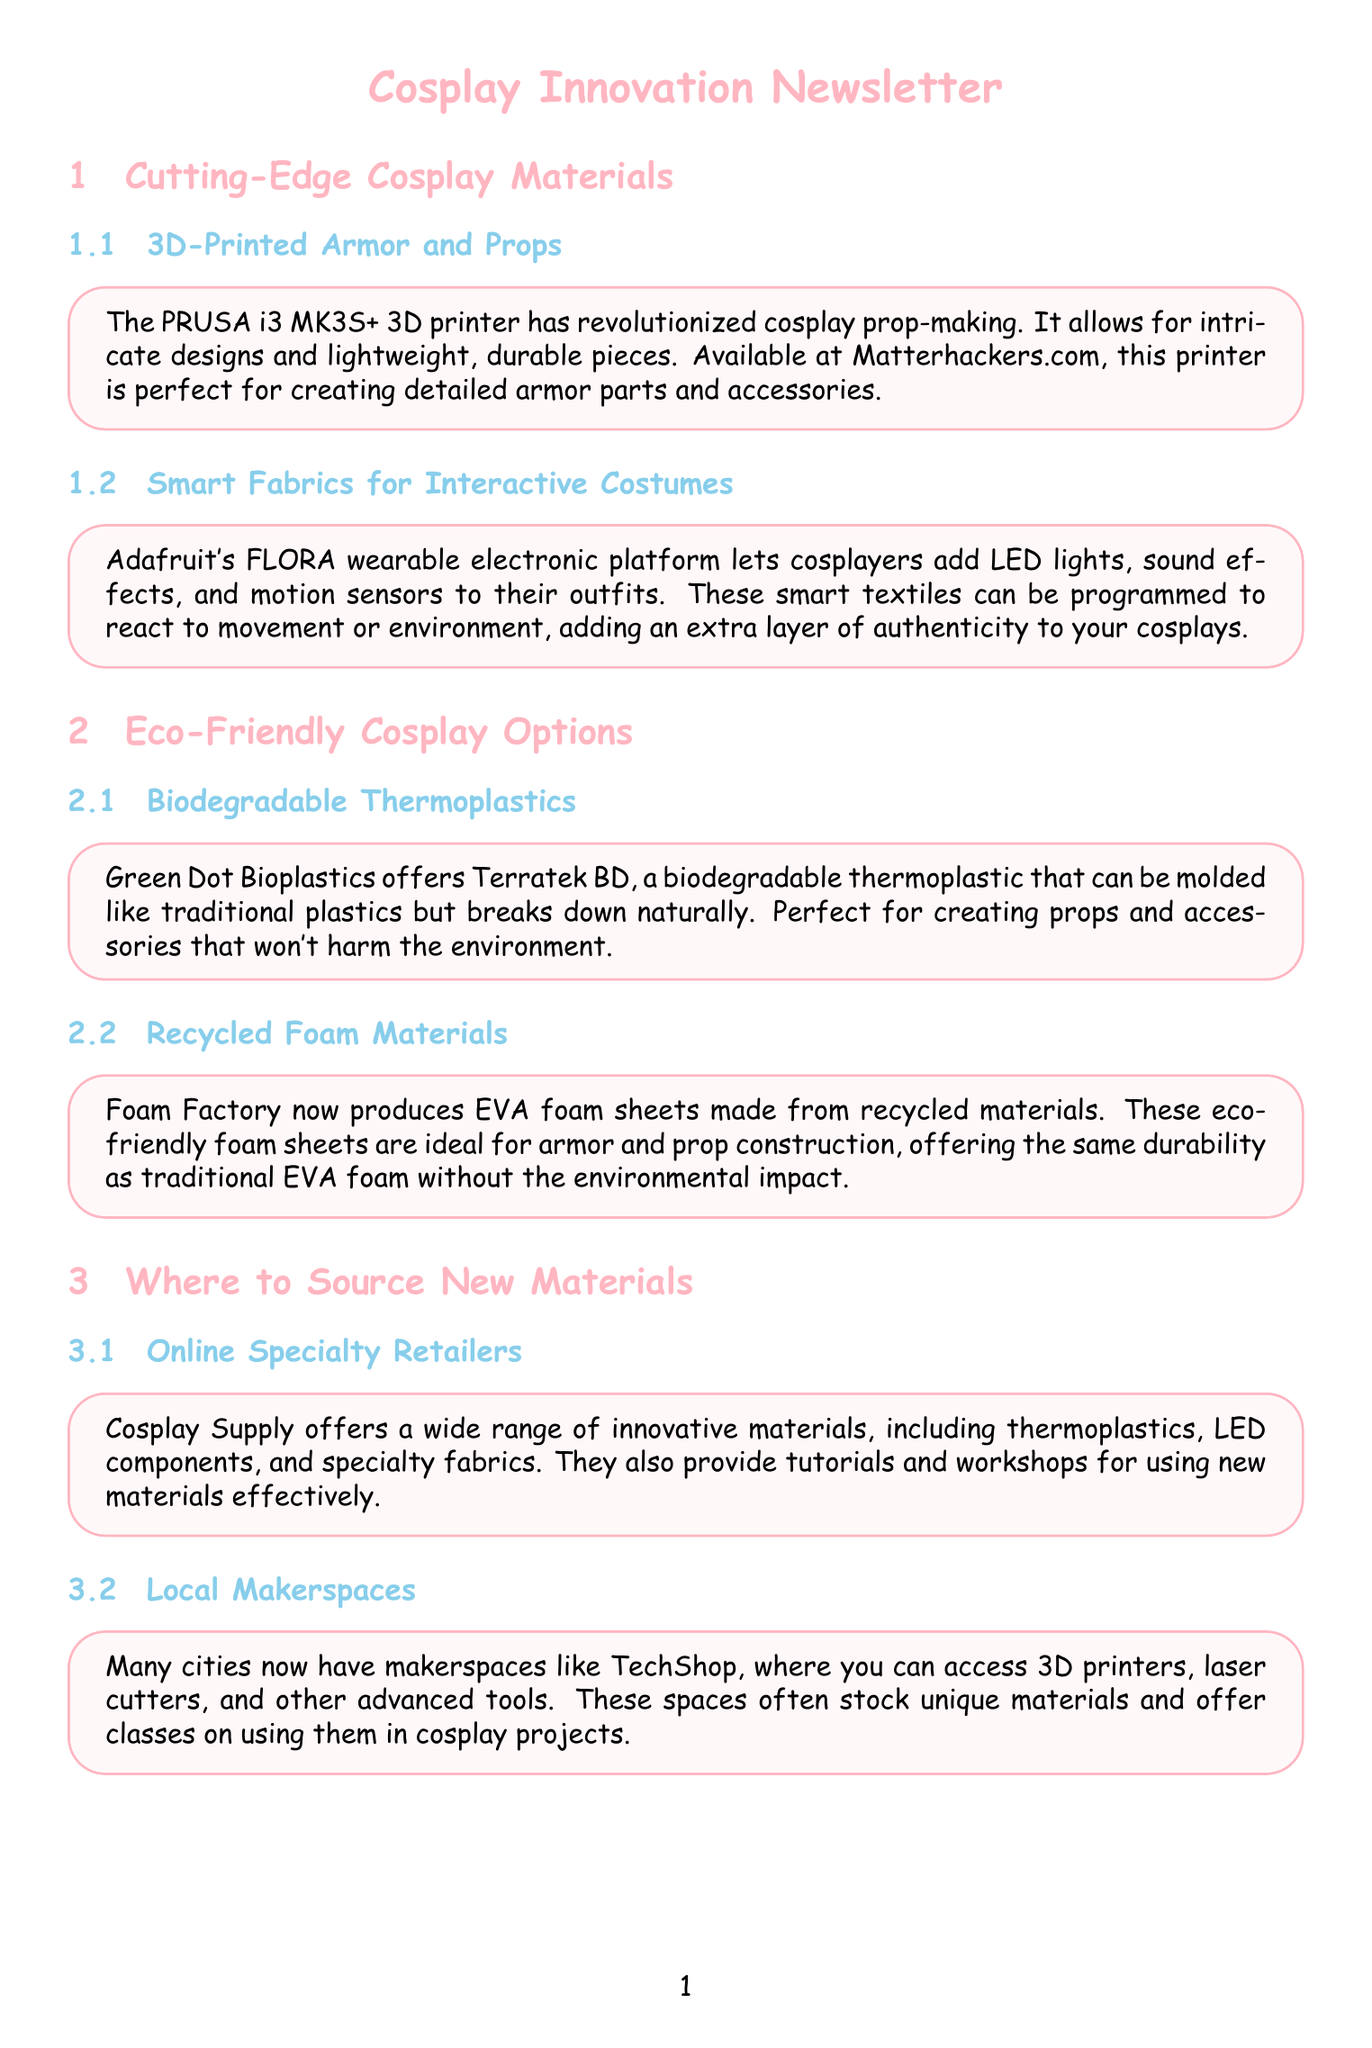What printer has revolutionized cosplay prop-making? The document specifies the PRUSA i3 MK3S+ as the printer that has revolutionized cosplay prop-making.
Answer: PRUSA i3 MK3S+ What is the main advantage of the Terratek BD thermoplastic? The document states that it is biodegradable and can break down naturally, distinguishing it from traditional plastics.
Answer: Biodegradable Which online retailer offers materials such as thermoplastics and LED components? The document mentions Cosplay Supply as the retailer that offers a wide range of innovative materials.
Answer: Cosplay Supply What type of paint does Createx Colors offer for cosplaying? According to the document, Createx Colors offers water-based airbrush paints, highlighting their suitability for cosplay.
Answer: Water-based airbrush paints Which technology allows cosplayers to create complex shapes quickly? The document highlights the Formech 508DT vacuum forming machine as the technology for creating complex shapes.
Answer: Formech 508DT What are the recycled materials used by Foam Factory? The document indicates that Foam Factory produces EVA foam sheets made from recycled materials, focusing on eco-friendliness.
Answer: EVA foam sheets How can Adafruit's FLORA platform enhance a costume? The document explains that Adafruit's FLORA allows for adding LED lights, sound effects, and motion sensors to costumes.
Answer: LED lights, sound effects, and motion sensors What is the main focus of the newsletter? The primary focus is on innovations in cosplay materials and their sourcing, including eco-friendly options.
Answer: Innovations in cosplay materials and sourcing 